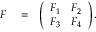<formula> <loc_0><loc_0><loc_500><loc_500>\begin{array} { r l r } { F } & = } & { \left ( \begin{array} { l l } { F _ { 1 } } & { F _ { 2 } } \\ { F _ { 3 } } & { F _ { 4 } } \end{array} \right ) . } \end{array}</formula> 